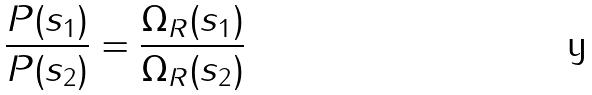<formula> <loc_0><loc_0><loc_500><loc_500>\frac { P ( s _ { 1 } ) } { P ( s _ { 2 } ) } = \frac { \Omega _ { R } ( s _ { 1 } ) } { \Omega _ { R } ( s _ { 2 } ) }</formula> 